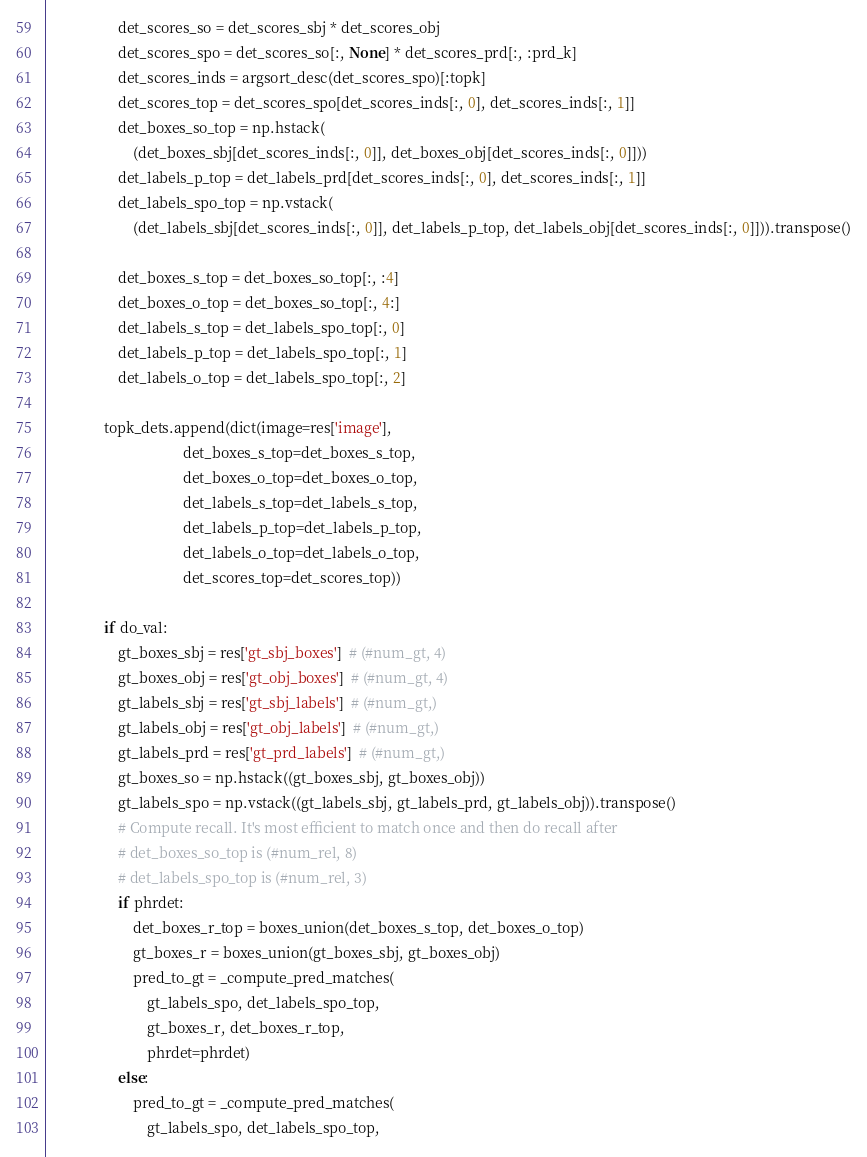<code> <loc_0><loc_0><loc_500><loc_500><_Python_>                    det_scores_so = det_scores_sbj * det_scores_obj
                    det_scores_spo = det_scores_so[:, None] * det_scores_prd[:, :prd_k]
                    det_scores_inds = argsort_desc(det_scores_spo)[:topk]
                    det_scores_top = det_scores_spo[det_scores_inds[:, 0], det_scores_inds[:, 1]]
                    det_boxes_so_top = np.hstack(
                        (det_boxes_sbj[det_scores_inds[:, 0]], det_boxes_obj[det_scores_inds[:, 0]]))
                    det_labels_p_top = det_labels_prd[det_scores_inds[:, 0], det_scores_inds[:, 1]]
                    det_labels_spo_top = np.vstack(
                        (det_labels_sbj[det_scores_inds[:, 0]], det_labels_p_top, det_labels_obj[det_scores_inds[:, 0]])).transpose()

                    det_boxes_s_top = det_boxes_so_top[:, :4]
                    det_boxes_o_top = det_boxes_so_top[:, 4:]
                    det_labels_s_top = det_labels_spo_top[:, 0]
                    det_labels_p_top = det_labels_spo_top[:, 1]
                    det_labels_o_top = det_labels_spo_top[:, 2]

                topk_dets.append(dict(image=res['image'],
                                      det_boxes_s_top=det_boxes_s_top,
                                      det_boxes_o_top=det_boxes_o_top,
                                      det_labels_s_top=det_labels_s_top,
                                      det_labels_p_top=det_labels_p_top,
                                      det_labels_o_top=det_labels_o_top,
                                      det_scores_top=det_scores_top))

                if do_val:
                    gt_boxes_sbj = res['gt_sbj_boxes']  # (#num_gt, 4)
                    gt_boxes_obj = res['gt_obj_boxes']  # (#num_gt, 4)
                    gt_labels_sbj = res['gt_sbj_labels']  # (#num_gt,)
                    gt_labels_obj = res['gt_obj_labels']  # (#num_gt,)
                    gt_labels_prd = res['gt_prd_labels']  # (#num_gt,)
                    gt_boxes_so = np.hstack((gt_boxes_sbj, gt_boxes_obj))
                    gt_labels_spo = np.vstack((gt_labels_sbj, gt_labels_prd, gt_labels_obj)).transpose()
                    # Compute recall. It's most efficient to match once and then do recall after
                    # det_boxes_so_top is (#num_rel, 8)
                    # det_labels_spo_top is (#num_rel, 3)
                    if phrdet:
                        det_boxes_r_top = boxes_union(det_boxes_s_top, det_boxes_o_top)
                        gt_boxes_r = boxes_union(gt_boxes_sbj, gt_boxes_obj)
                        pred_to_gt = _compute_pred_matches(
                            gt_labels_spo, det_labels_spo_top,
                            gt_boxes_r, det_boxes_r_top,
                            phrdet=phrdet)
                    else:
                        pred_to_gt = _compute_pred_matches(
                            gt_labels_spo, det_labels_spo_top,</code> 